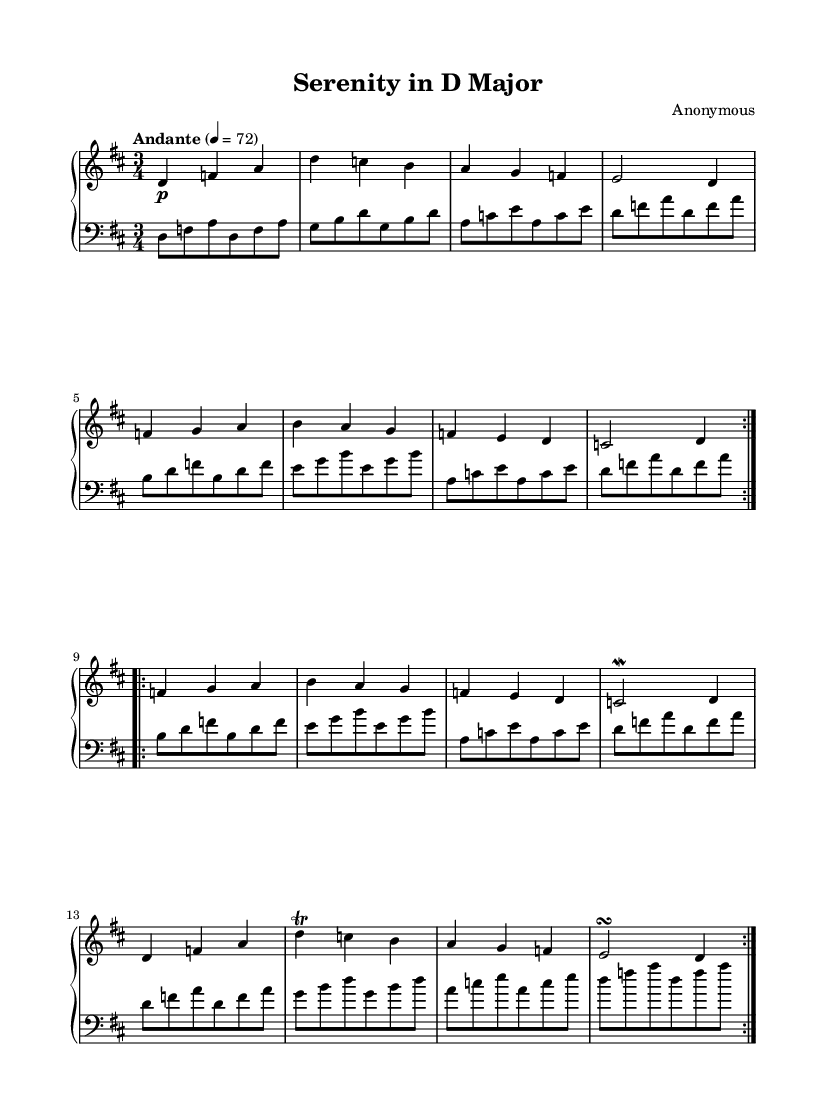What is the key signature of this music? The key signature indicates that there are two sharps (F# and C#) in the music, which corresponds to D major.
Answer: D major What is the time signature of the piece? The time signature is shown as a fraction at the beginning of the music. In this case, it is 3 over 4, indicating three beats per measure with a quarter note receiving one beat.
Answer: 3/4 What tempo marking is used in this composition? The tempo marking is usually written at the beginning of the score, stating how fast the piece should be played. Here, it is marked "Andante," which is typically understood to mean a moderately slow pace.
Answer: Andante How many times is the first section repeated? The first section of the piece is noted to have a repeat sign (two volta repeats), meaning it is to be played twice before moving on to the next section.
Answer: 2 Identify a musical ornament used in this piece. An ornament is a decorative musical embellishment that is indicated on the score. In this piece, a trill and a mordent are found, which give the music a characteristic Baroque flourish.
Answer: Trill, mordent What is the primary texture of the music? Analyzing the written arrangement and instrumental groups, we can see that this composition features a clear division between the right-hand melodic line and the left-hand accompaniment, typical of Baroque music.
Answer: Homophonic What is a characteristic feature of Baroque music found in this score? The score shows features such as ornamentation (trills and mordents) and a clear delineation of melody and harmony, which are hallmark characteristics of Baroque music.
Answer: Ornamentation 